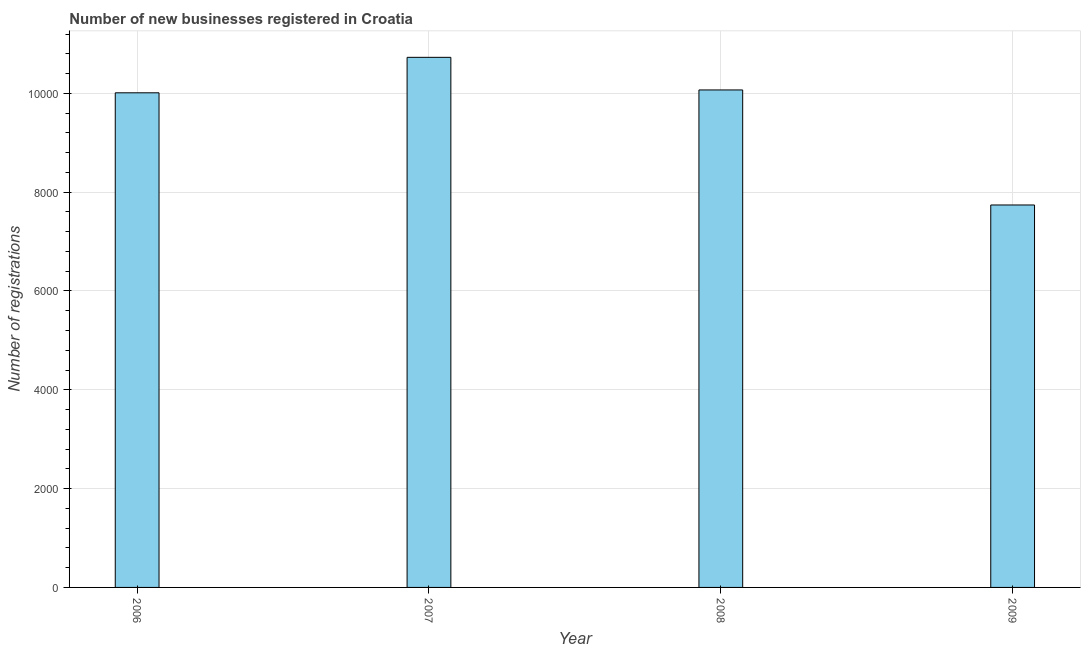What is the title of the graph?
Provide a succinct answer. Number of new businesses registered in Croatia. What is the label or title of the X-axis?
Make the answer very short. Year. What is the label or title of the Y-axis?
Your answer should be very brief. Number of registrations. What is the number of new business registrations in 2006?
Give a very brief answer. 1.00e+04. Across all years, what is the maximum number of new business registrations?
Offer a very short reply. 1.07e+04. Across all years, what is the minimum number of new business registrations?
Your answer should be very brief. 7740. In which year was the number of new business registrations maximum?
Your answer should be compact. 2007. What is the sum of the number of new business registrations?
Provide a short and direct response. 3.85e+04. What is the difference between the number of new business registrations in 2008 and 2009?
Your response must be concise. 2328. What is the average number of new business registrations per year?
Provide a short and direct response. 9636. What is the median number of new business registrations?
Your answer should be compact. 1.00e+04. What is the ratio of the number of new business registrations in 2007 to that in 2009?
Offer a terse response. 1.39. Is the difference between the number of new business registrations in 2007 and 2008 greater than the difference between any two years?
Your answer should be very brief. No. What is the difference between the highest and the second highest number of new business registrations?
Offer a terse response. 660. What is the difference between the highest and the lowest number of new business registrations?
Make the answer very short. 2988. Are all the bars in the graph horizontal?
Offer a terse response. No. What is the difference between two consecutive major ticks on the Y-axis?
Offer a very short reply. 2000. Are the values on the major ticks of Y-axis written in scientific E-notation?
Your answer should be very brief. No. What is the Number of registrations of 2006?
Your answer should be compact. 1.00e+04. What is the Number of registrations in 2007?
Provide a short and direct response. 1.07e+04. What is the Number of registrations in 2008?
Provide a short and direct response. 1.01e+04. What is the Number of registrations in 2009?
Your answer should be compact. 7740. What is the difference between the Number of registrations in 2006 and 2007?
Your answer should be compact. -718. What is the difference between the Number of registrations in 2006 and 2008?
Ensure brevity in your answer.  -58. What is the difference between the Number of registrations in 2006 and 2009?
Your answer should be very brief. 2270. What is the difference between the Number of registrations in 2007 and 2008?
Your answer should be very brief. 660. What is the difference between the Number of registrations in 2007 and 2009?
Keep it short and to the point. 2988. What is the difference between the Number of registrations in 2008 and 2009?
Your response must be concise. 2328. What is the ratio of the Number of registrations in 2006 to that in 2007?
Your response must be concise. 0.93. What is the ratio of the Number of registrations in 2006 to that in 2008?
Keep it short and to the point. 0.99. What is the ratio of the Number of registrations in 2006 to that in 2009?
Provide a succinct answer. 1.29. What is the ratio of the Number of registrations in 2007 to that in 2008?
Ensure brevity in your answer.  1.07. What is the ratio of the Number of registrations in 2007 to that in 2009?
Your answer should be compact. 1.39. What is the ratio of the Number of registrations in 2008 to that in 2009?
Offer a terse response. 1.3. 